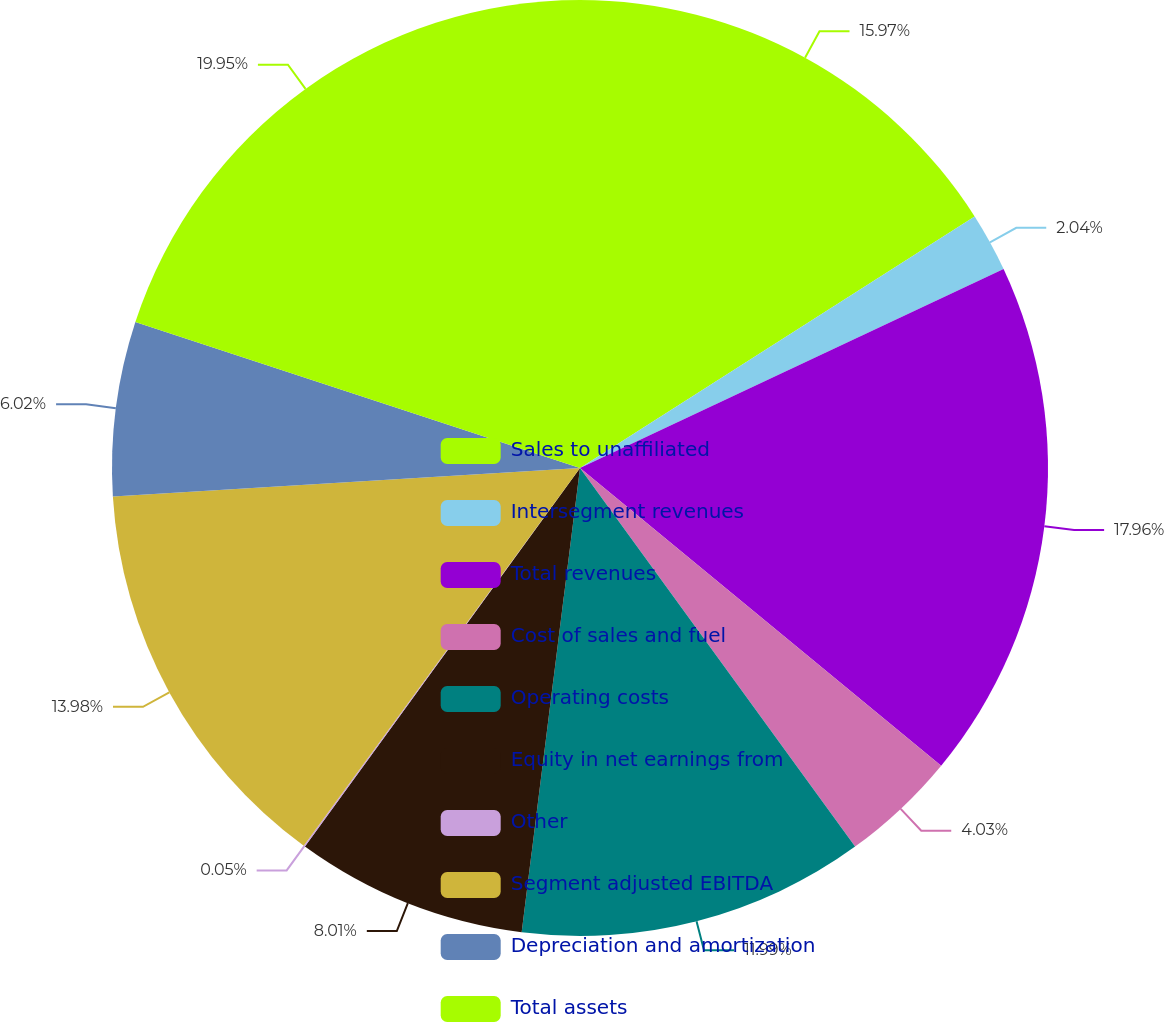Convert chart to OTSL. <chart><loc_0><loc_0><loc_500><loc_500><pie_chart><fcel>Sales to unaffiliated<fcel>Intersegment revenues<fcel>Total revenues<fcel>Cost of sales and fuel<fcel>Operating costs<fcel>Equity in net earnings from<fcel>Other<fcel>Segment adjusted EBITDA<fcel>Depreciation and amortization<fcel>Total assets<nl><fcel>15.97%<fcel>2.04%<fcel>17.96%<fcel>4.03%<fcel>11.99%<fcel>8.01%<fcel>0.05%<fcel>13.98%<fcel>6.02%<fcel>19.95%<nl></chart> 